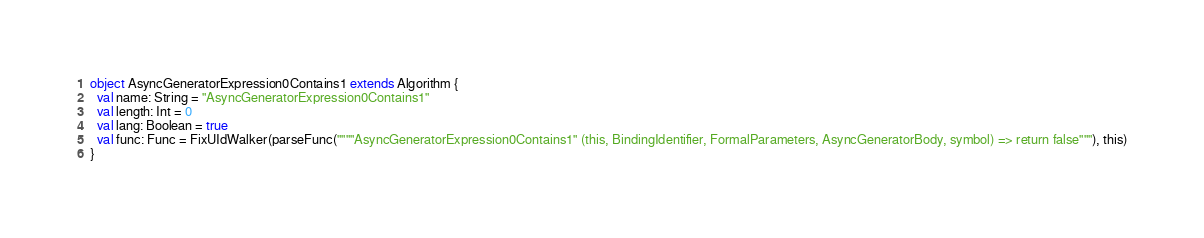<code> <loc_0><loc_0><loc_500><loc_500><_Scala_>object AsyncGeneratorExpression0Contains1 extends Algorithm {
  val name: String = "AsyncGeneratorExpression0Contains1"
  val length: Int = 0
  val lang: Boolean = true
  val func: Func = FixUIdWalker(parseFunc(""""AsyncGeneratorExpression0Contains1" (this, BindingIdentifier, FormalParameters, AsyncGeneratorBody, symbol) => return false"""), this)
}
</code> 